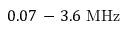<formula> <loc_0><loc_0><loc_500><loc_500>0 . 0 7 - 3 . 6 M H z</formula> 